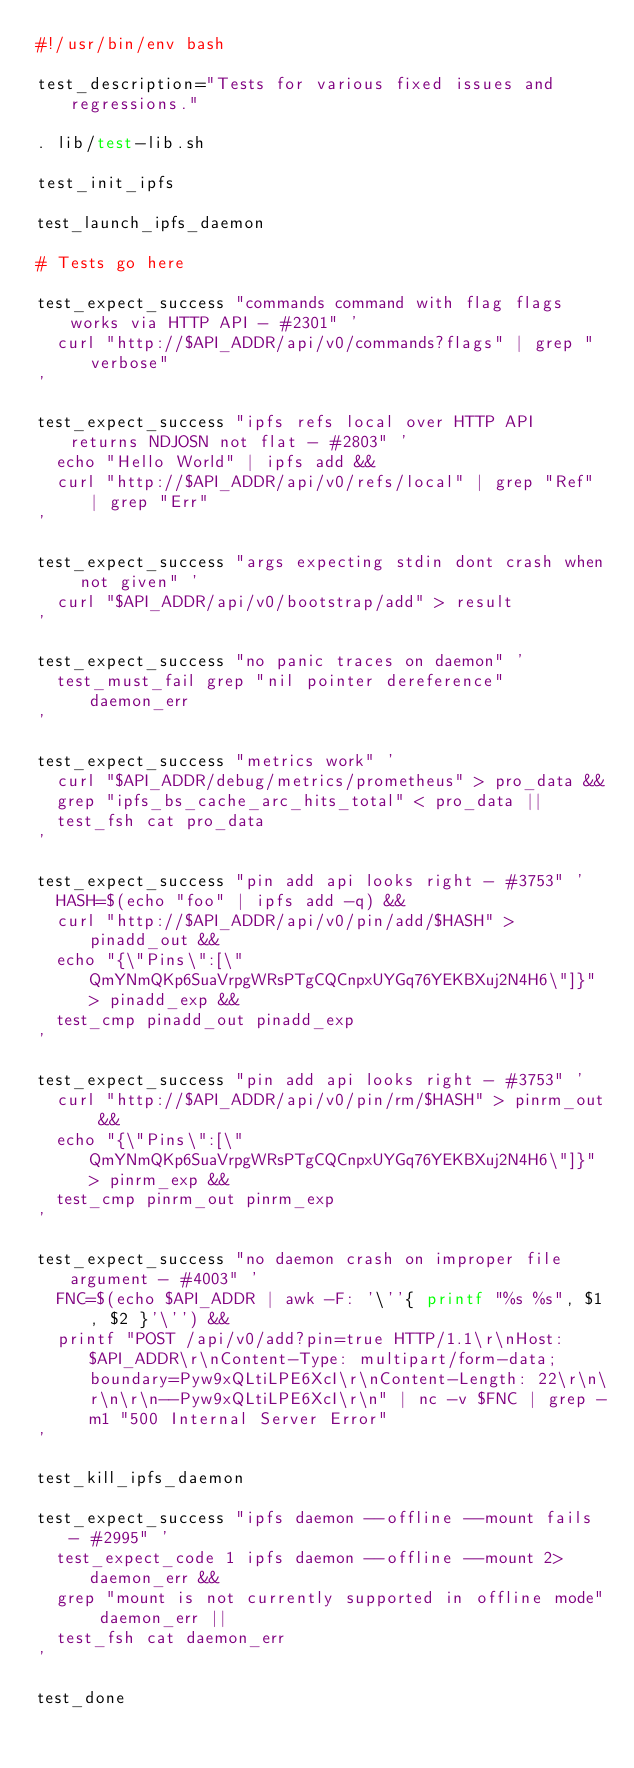<code> <loc_0><loc_0><loc_500><loc_500><_Bash_>#!/usr/bin/env bash

test_description="Tests for various fixed issues and regressions."

. lib/test-lib.sh

test_init_ipfs

test_launch_ipfs_daemon

# Tests go here

test_expect_success "commands command with flag flags works via HTTP API - #2301" '
  curl "http://$API_ADDR/api/v0/commands?flags" | grep "verbose"
'

test_expect_success "ipfs refs local over HTTP API returns NDJOSN not flat - #2803" '
  echo "Hello World" | ipfs add &&
  curl "http://$API_ADDR/api/v0/refs/local" | grep "Ref" | grep "Err"
'

test_expect_success "args expecting stdin dont crash when not given" '
  curl "$API_ADDR/api/v0/bootstrap/add" > result
'

test_expect_success "no panic traces on daemon" '
  test_must_fail grep "nil pointer dereference" daemon_err
'

test_expect_success "metrics work" '
  curl "$API_ADDR/debug/metrics/prometheus" > pro_data &&
  grep "ipfs_bs_cache_arc_hits_total" < pro_data ||
  test_fsh cat pro_data
'

test_expect_success "pin add api looks right - #3753" '
  HASH=$(echo "foo" | ipfs add -q) &&
  curl "http://$API_ADDR/api/v0/pin/add/$HASH" > pinadd_out &&
  echo "{\"Pins\":[\"QmYNmQKp6SuaVrpgWRsPTgCQCnpxUYGq76YEKBXuj2N4H6\"]}" > pinadd_exp &&
  test_cmp pinadd_out pinadd_exp
'

test_expect_success "pin add api looks right - #3753" '
  curl "http://$API_ADDR/api/v0/pin/rm/$HASH" > pinrm_out &&
  echo "{\"Pins\":[\"QmYNmQKp6SuaVrpgWRsPTgCQCnpxUYGq76YEKBXuj2N4H6\"]}" > pinrm_exp &&
  test_cmp pinrm_out pinrm_exp
'

test_expect_success "no daemon crash on improper file argument - #4003" '
  FNC=$(echo $API_ADDR | awk -F: '\''{ printf "%s %s", $1, $2 }'\'') &&
  printf "POST /api/v0/add?pin=true HTTP/1.1\r\nHost: $API_ADDR\r\nContent-Type: multipart/form-data; boundary=Pyw9xQLtiLPE6XcI\r\nContent-Length: 22\r\n\r\n\r\n--Pyw9xQLtiLPE6XcI\r\n" | nc -v $FNC | grep -m1 "500 Internal Server Error"
'

test_kill_ipfs_daemon

test_expect_success "ipfs daemon --offline --mount fails - #2995" '
  test_expect_code 1 ipfs daemon --offline --mount 2>daemon_err &&
  grep "mount is not currently supported in offline mode" daemon_err ||
  test_fsh cat daemon_err
'

test_done

</code> 